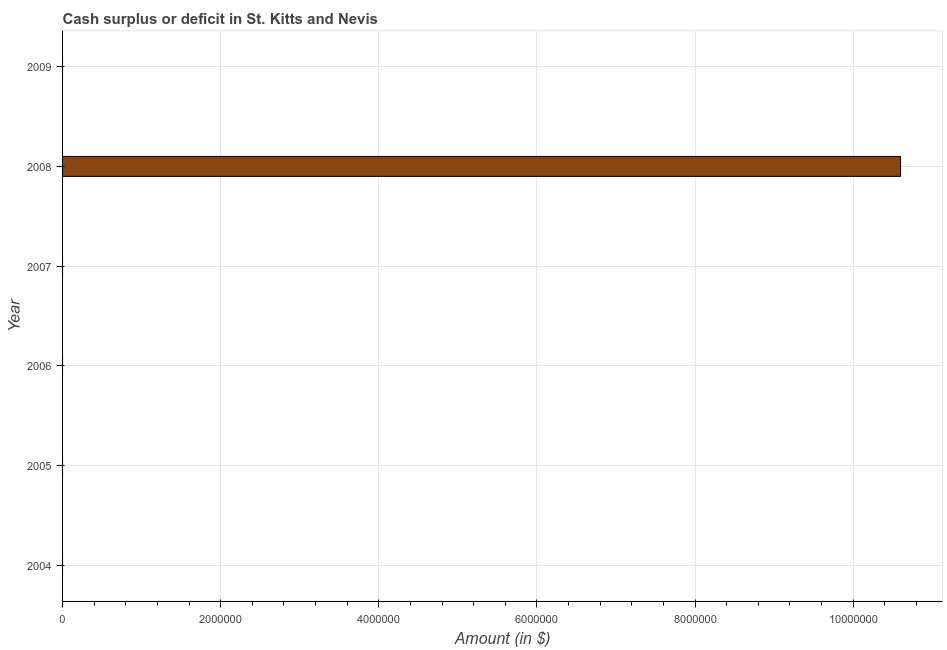Does the graph contain any zero values?
Keep it short and to the point. Yes. Does the graph contain grids?
Give a very brief answer. Yes. What is the title of the graph?
Keep it short and to the point. Cash surplus or deficit in St. Kitts and Nevis. What is the label or title of the X-axis?
Offer a terse response. Amount (in $). Across all years, what is the maximum cash surplus or deficit?
Give a very brief answer. 1.06e+07. In which year was the cash surplus or deficit maximum?
Provide a short and direct response. 2008. What is the sum of the cash surplus or deficit?
Keep it short and to the point. 1.06e+07. What is the average cash surplus or deficit per year?
Ensure brevity in your answer.  1.77e+06. What is the median cash surplus or deficit?
Your answer should be compact. 0. What is the difference between the highest and the lowest cash surplus or deficit?
Your answer should be very brief. 1.06e+07. Are all the bars in the graph horizontal?
Provide a short and direct response. Yes. How many years are there in the graph?
Provide a succinct answer. 6. What is the Amount (in $) of 2005?
Offer a terse response. 0. What is the Amount (in $) of 2006?
Your answer should be compact. 0. What is the Amount (in $) in 2008?
Ensure brevity in your answer.  1.06e+07. What is the Amount (in $) in 2009?
Your response must be concise. 0. 